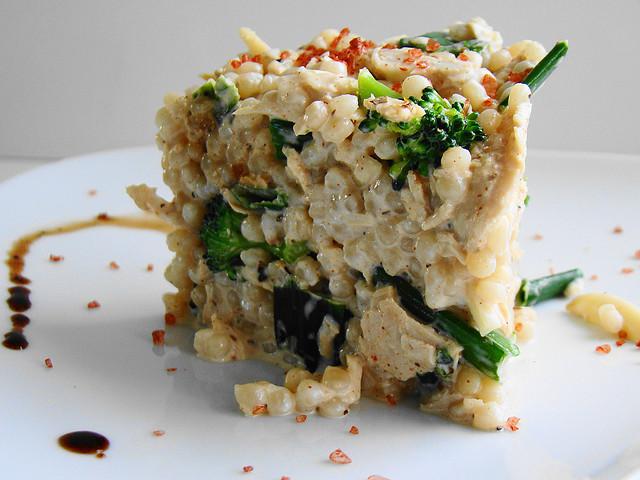What is the green stuff?
Be succinct. Broccoli. What kind of pie is this?
Quick response, please. Vegetable. Is there glaze on the plate?
Give a very brief answer. Yes. What is under the beans?
Concise answer only. Plate. Has this plate of food already been served?
Be succinct. Yes. Is there a crust around the pie?
Keep it brief. No. What kind of food is this?
Give a very brief answer. Quiche. What foods are pictured on the white plate?
Write a very short answer. Rice cake. Is this a piece of cake?
Concise answer only. No. 